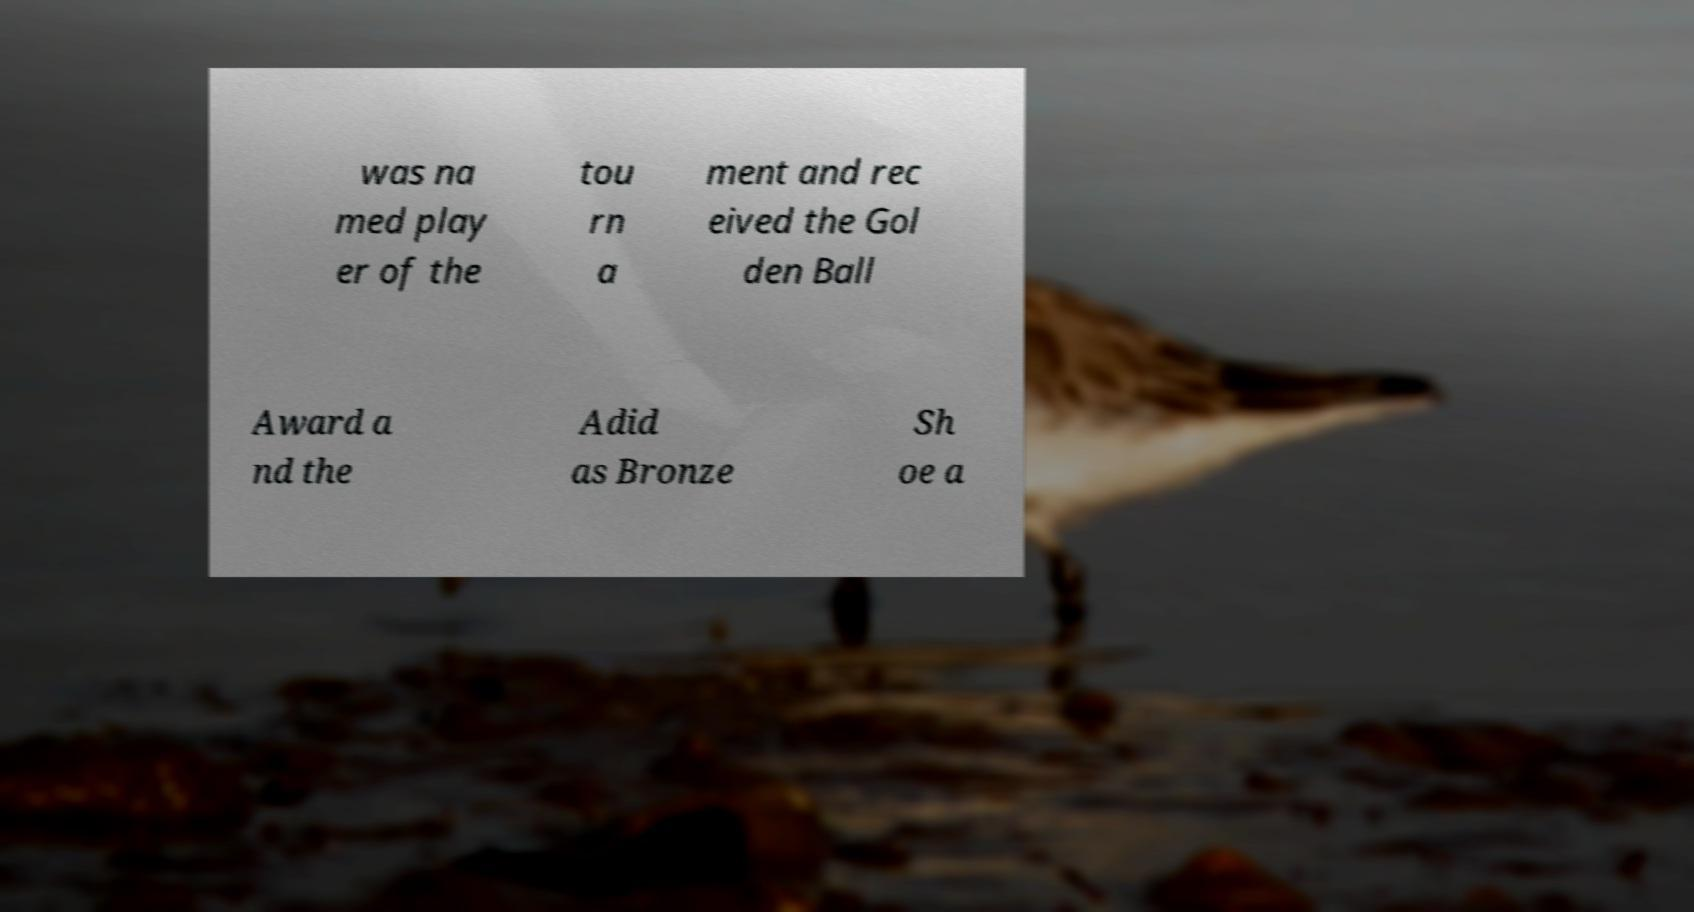There's text embedded in this image that I need extracted. Can you transcribe it verbatim? was na med play er of the tou rn a ment and rec eived the Gol den Ball Award a nd the Adid as Bronze Sh oe a 